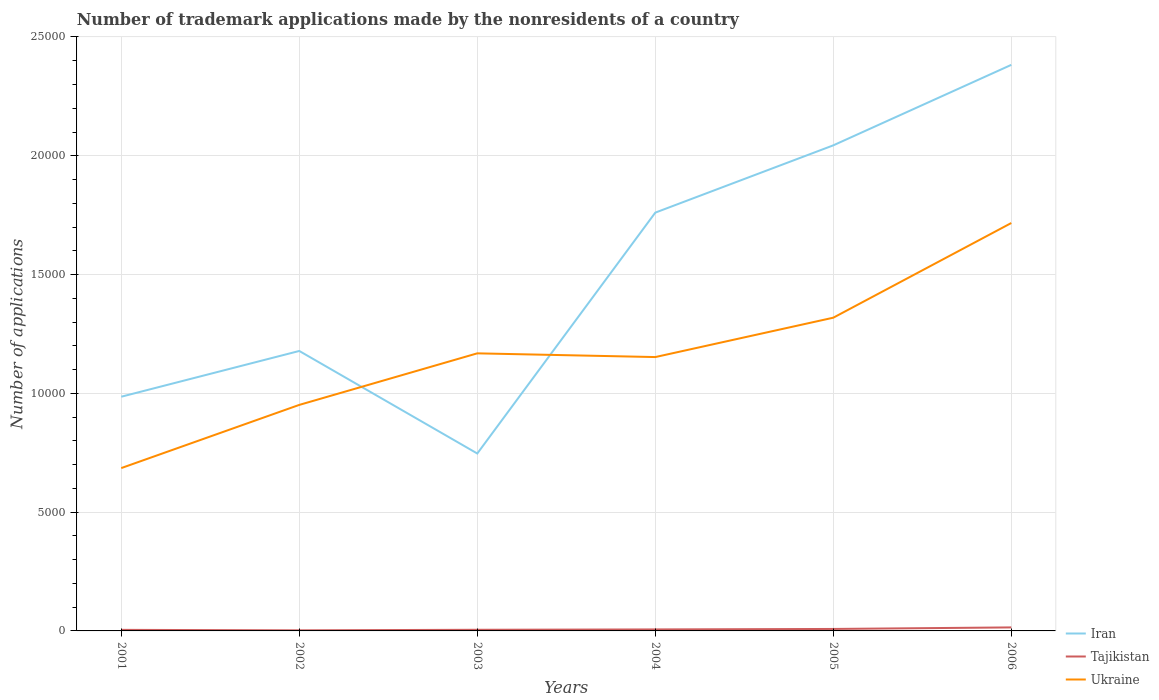Does the line corresponding to Tajikistan intersect with the line corresponding to Iran?
Your answer should be compact. No. Across all years, what is the maximum number of trademark applications made by the nonresidents in Ukraine?
Offer a very short reply. 6854. What is the total number of trademark applications made by the nonresidents in Tajikistan in the graph?
Offer a very short reply. -100. What is the difference between the highest and the second highest number of trademark applications made by the nonresidents in Tajikistan?
Provide a short and direct response. 123. What is the difference between the highest and the lowest number of trademark applications made by the nonresidents in Iran?
Your answer should be compact. 3. How many years are there in the graph?
Your answer should be very brief. 6. Does the graph contain any zero values?
Provide a succinct answer. No. Where does the legend appear in the graph?
Provide a succinct answer. Bottom right. How are the legend labels stacked?
Your answer should be very brief. Vertical. What is the title of the graph?
Your answer should be very brief. Number of trademark applications made by the nonresidents of a country. Does "China" appear as one of the legend labels in the graph?
Your response must be concise. No. What is the label or title of the X-axis?
Give a very brief answer. Years. What is the label or title of the Y-axis?
Your answer should be very brief. Number of applications. What is the Number of applications of Iran in 2001?
Provide a short and direct response. 9858. What is the Number of applications of Ukraine in 2001?
Offer a very short reply. 6854. What is the Number of applications of Iran in 2002?
Make the answer very short. 1.18e+04. What is the Number of applications in Ukraine in 2002?
Provide a succinct answer. 9514. What is the Number of applications of Iran in 2003?
Your answer should be compact. 7468. What is the Number of applications of Ukraine in 2003?
Your answer should be very brief. 1.17e+04. What is the Number of applications in Iran in 2004?
Ensure brevity in your answer.  1.76e+04. What is the Number of applications in Ukraine in 2004?
Make the answer very short. 1.15e+04. What is the Number of applications of Iran in 2005?
Your answer should be compact. 2.04e+04. What is the Number of applications of Ukraine in 2005?
Keep it short and to the point. 1.32e+04. What is the Number of applications in Iran in 2006?
Ensure brevity in your answer.  2.38e+04. What is the Number of applications in Tajikistan in 2006?
Provide a short and direct response. 148. What is the Number of applications of Ukraine in 2006?
Your answer should be very brief. 1.72e+04. Across all years, what is the maximum Number of applications in Iran?
Provide a short and direct response. 2.38e+04. Across all years, what is the maximum Number of applications of Tajikistan?
Give a very brief answer. 148. Across all years, what is the maximum Number of applications in Ukraine?
Provide a succinct answer. 1.72e+04. Across all years, what is the minimum Number of applications of Iran?
Provide a succinct answer. 7468. Across all years, what is the minimum Number of applications in Ukraine?
Ensure brevity in your answer.  6854. What is the total Number of applications in Iran in the graph?
Make the answer very short. 9.10e+04. What is the total Number of applications of Tajikistan in the graph?
Your response must be concise. 412. What is the total Number of applications in Ukraine in the graph?
Your answer should be very brief. 6.99e+04. What is the difference between the Number of applications of Iran in 2001 and that in 2002?
Your response must be concise. -1926. What is the difference between the Number of applications of Ukraine in 2001 and that in 2002?
Provide a short and direct response. -2660. What is the difference between the Number of applications in Iran in 2001 and that in 2003?
Offer a terse response. 2390. What is the difference between the Number of applications in Ukraine in 2001 and that in 2003?
Your answer should be very brief. -4830. What is the difference between the Number of applications in Iran in 2001 and that in 2004?
Make the answer very short. -7749. What is the difference between the Number of applications of Tajikistan in 2001 and that in 2004?
Give a very brief answer. -18. What is the difference between the Number of applications of Ukraine in 2001 and that in 2004?
Give a very brief answer. -4673. What is the difference between the Number of applications of Iran in 2001 and that in 2005?
Offer a terse response. -1.06e+04. What is the difference between the Number of applications of Tajikistan in 2001 and that in 2005?
Your answer should be compact. -38. What is the difference between the Number of applications in Ukraine in 2001 and that in 2005?
Make the answer very short. -6330. What is the difference between the Number of applications of Iran in 2001 and that in 2006?
Offer a terse response. -1.40e+04. What is the difference between the Number of applications in Tajikistan in 2001 and that in 2006?
Offer a terse response. -103. What is the difference between the Number of applications in Ukraine in 2001 and that in 2006?
Make the answer very short. -1.03e+04. What is the difference between the Number of applications in Iran in 2002 and that in 2003?
Ensure brevity in your answer.  4316. What is the difference between the Number of applications of Tajikistan in 2002 and that in 2003?
Your answer should be compact. -23. What is the difference between the Number of applications of Ukraine in 2002 and that in 2003?
Make the answer very short. -2170. What is the difference between the Number of applications in Iran in 2002 and that in 2004?
Keep it short and to the point. -5823. What is the difference between the Number of applications in Tajikistan in 2002 and that in 2004?
Offer a terse response. -38. What is the difference between the Number of applications in Ukraine in 2002 and that in 2004?
Make the answer very short. -2013. What is the difference between the Number of applications in Iran in 2002 and that in 2005?
Your answer should be very brief. -8655. What is the difference between the Number of applications in Tajikistan in 2002 and that in 2005?
Your answer should be very brief. -58. What is the difference between the Number of applications in Ukraine in 2002 and that in 2005?
Your answer should be very brief. -3670. What is the difference between the Number of applications of Iran in 2002 and that in 2006?
Provide a short and direct response. -1.20e+04. What is the difference between the Number of applications in Tajikistan in 2002 and that in 2006?
Give a very brief answer. -123. What is the difference between the Number of applications of Ukraine in 2002 and that in 2006?
Offer a terse response. -7656. What is the difference between the Number of applications in Iran in 2003 and that in 2004?
Make the answer very short. -1.01e+04. What is the difference between the Number of applications in Tajikistan in 2003 and that in 2004?
Keep it short and to the point. -15. What is the difference between the Number of applications of Ukraine in 2003 and that in 2004?
Give a very brief answer. 157. What is the difference between the Number of applications in Iran in 2003 and that in 2005?
Your response must be concise. -1.30e+04. What is the difference between the Number of applications of Tajikistan in 2003 and that in 2005?
Your response must be concise. -35. What is the difference between the Number of applications of Ukraine in 2003 and that in 2005?
Provide a succinct answer. -1500. What is the difference between the Number of applications of Iran in 2003 and that in 2006?
Offer a terse response. -1.64e+04. What is the difference between the Number of applications in Tajikistan in 2003 and that in 2006?
Offer a terse response. -100. What is the difference between the Number of applications in Ukraine in 2003 and that in 2006?
Your response must be concise. -5486. What is the difference between the Number of applications in Iran in 2004 and that in 2005?
Your response must be concise. -2832. What is the difference between the Number of applications in Ukraine in 2004 and that in 2005?
Offer a very short reply. -1657. What is the difference between the Number of applications of Iran in 2004 and that in 2006?
Your answer should be very brief. -6220. What is the difference between the Number of applications of Tajikistan in 2004 and that in 2006?
Keep it short and to the point. -85. What is the difference between the Number of applications of Ukraine in 2004 and that in 2006?
Ensure brevity in your answer.  -5643. What is the difference between the Number of applications of Iran in 2005 and that in 2006?
Your response must be concise. -3388. What is the difference between the Number of applications in Tajikistan in 2005 and that in 2006?
Provide a succinct answer. -65. What is the difference between the Number of applications of Ukraine in 2005 and that in 2006?
Offer a terse response. -3986. What is the difference between the Number of applications in Iran in 2001 and the Number of applications in Tajikistan in 2002?
Provide a succinct answer. 9833. What is the difference between the Number of applications of Iran in 2001 and the Number of applications of Ukraine in 2002?
Your answer should be compact. 344. What is the difference between the Number of applications in Tajikistan in 2001 and the Number of applications in Ukraine in 2002?
Offer a terse response. -9469. What is the difference between the Number of applications in Iran in 2001 and the Number of applications in Tajikistan in 2003?
Your response must be concise. 9810. What is the difference between the Number of applications of Iran in 2001 and the Number of applications of Ukraine in 2003?
Make the answer very short. -1826. What is the difference between the Number of applications of Tajikistan in 2001 and the Number of applications of Ukraine in 2003?
Provide a succinct answer. -1.16e+04. What is the difference between the Number of applications in Iran in 2001 and the Number of applications in Tajikistan in 2004?
Your answer should be compact. 9795. What is the difference between the Number of applications of Iran in 2001 and the Number of applications of Ukraine in 2004?
Your answer should be compact. -1669. What is the difference between the Number of applications in Tajikistan in 2001 and the Number of applications in Ukraine in 2004?
Make the answer very short. -1.15e+04. What is the difference between the Number of applications in Iran in 2001 and the Number of applications in Tajikistan in 2005?
Offer a terse response. 9775. What is the difference between the Number of applications of Iran in 2001 and the Number of applications of Ukraine in 2005?
Make the answer very short. -3326. What is the difference between the Number of applications in Tajikistan in 2001 and the Number of applications in Ukraine in 2005?
Your response must be concise. -1.31e+04. What is the difference between the Number of applications in Iran in 2001 and the Number of applications in Tajikistan in 2006?
Provide a short and direct response. 9710. What is the difference between the Number of applications in Iran in 2001 and the Number of applications in Ukraine in 2006?
Ensure brevity in your answer.  -7312. What is the difference between the Number of applications in Tajikistan in 2001 and the Number of applications in Ukraine in 2006?
Provide a succinct answer. -1.71e+04. What is the difference between the Number of applications of Iran in 2002 and the Number of applications of Tajikistan in 2003?
Offer a very short reply. 1.17e+04. What is the difference between the Number of applications of Iran in 2002 and the Number of applications of Ukraine in 2003?
Provide a short and direct response. 100. What is the difference between the Number of applications of Tajikistan in 2002 and the Number of applications of Ukraine in 2003?
Keep it short and to the point. -1.17e+04. What is the difference between the Number of applications in Iran in 2002 and the Number of applications in Tajikistan in 2004?
Provide a succinct answer. 1.17e+04. What is the difference between the Number of applications in Iran in 2002 and the Number of applications in Ukraine in 2004?
Offer a very short reply. 257. What is the difference between the Number of applications of Tajikistan in 2002 and the Number of applications of Ukraine in 2004?
Your answer should be very brief. -1.15e+04. What is the difference between the Number of applications in Iran in 2002 and the Number of applications in Tajikistan in 2005?
Your answer should be compact. 1.17e+04. What is the difference between the Number of applications of Iran in 2002 and the Number of applications of Ukraine in 2005?
Offer a very short reply. -1400. What is the difference between the Number of applications in Tajikistan in 2002 and the Number of applications in Ukraine in 2005?
Keep it short and to the point. -1.32e+04. What is the difference between the Number of applications of Iran in 2002 and the Number of applications of Tajikistan in 2006?
Provide a short and direct response. 1.16e+04. What is the difference between the Number of applications in Iran in 2002 and the Number of applications in Ukraine in 2006?
Keep it short and to the point. -5386. What is the difference between the Number of applications of Tajikistan in 2002 and the Number of applications of Ukraine in 2006?
Offer a terse response. -1.71e+04. What is the difference between the Number of applications of Iran in 2003 and the Number of applications of Tajikistan in 2004?
Provide a succinct answer. 7405. What is the difference between the Number of applications in Iran in 2003 and the Number of applications in Ukraine in 2004?
Your response must be concise. -4059. What is the difference between the Number of applications of Tajikistan in 2003 and the Number of applications of Ukraine in 2004?
Offer a very short reply. -1.15e+04. What is the difference between the Number of applications of Iran in 2003 and the Number of applications of Tajikistan in 2005?
Offer a very short reply. 7385. What is the difference between the Number of applications in Iran in 2003 and the Number of applications in Ukraine in 2005?
Your answer should be very brief. -5716. What is the difference between the Number of applications in Tajikistan in 2003 and the Number of applications in Ukraine in 2005?
Give a very brief answer. -1.31e+04. What is the difference between the Number of applications of Iran in 2003 and the Number of applications of Tajikistan in 2006?
Offer a very short reply. 7320. What is the difference between the Number of applications in Iran in 2003 and the Number of applications in Ukraine in 2006?
Offer a terse response. -9702. What is the difference between the Number of applications in Tajikistan in 2003 and the Number of applications in Ukraine in 2006?
Keep it short and to the point. -1.71e+04. What is the difference between the Number of applications in Iran in 2004 and the Number of applications in Tajikistan in 2005?
Give a very brief answer. 1.75e+04. What is the difference between the Number of applications of Iran in 2004 and the Number of applications of Ukraine in 2005?
Provide a succinct answer. 4423. What is the difference between the Number of applications in Tajikistan in 2004 and the Number of applications in Ukraine in 2005?
Your answer should be compact. -1.31e+04. What is the difference between the Number of applications in Iran in 2004 and the Number of applications in Tajikistan in 2006?
Keep it short and to the point. 1.75e+04. What is the difference between the Number of applications in Iran in 2004 and the Number of applications in Ukraine in 2006?
Keep it short and to the point. 437. What is the difference between the Number of applications of Tajikistan in 2004 and the Number of applications of Ukraine in 2006?
Your response must be concise. -1.71e+04. What is the difference between the Number of applications in Iran in 2005 and the Number of applications in Tajikistan in 2006?
Your response must be concise. 2.03e+04. What is the difference between the Number of applications in Iran in 2005 and the Number of applications in Ukraine in 2006?
Provide a short and direct response. 3269. What is the difference between the Number of applications of Tajikistan in 2005 and the Number of applications of Ukraine in 2006?
Offer a very short reply. -1.71e+04. What is the average Number of applications of Iran per year?
Keep it short and to the point. 1.52e+04. What is the average Number of applications of Tajikistan per year?
Offer a terse response. 68.67. What is the average Number of applications in Ukraine per year?
Offer a very short reply. 1.17e+04. In the year 2001, what is the difference between the Number of applications in Iran and Number of applications in Tajikistan?
Your answer should be compact. 9813. In the year 2001, what is the difference between the Number of applications in Iran and Number of applications in Ukraine?
Ensure brevity in your answer.  3004. In the year 2001, what is the difference between the Number of applications in Tajikistan and Number of applications in Ukraine?
Offer a very short reply. -6809. In the year 2002, what is the difference between the Number of applications of Iran and Number of applications of Tajikistan?
Give a very brief answer. 1.18e+04. In the year 2002, what is the difference between the Number of applications in Iran and Number of applications in Ukraine?
Ensure brevity in your answer.  2270. In the year 2002, what is the difference between the Number of applications in Tajikistan and Number of applications in Ukraine?
Offer a very short reply. -9489. In the year 2003, what is the difference between the Number of applications of Iran and Number of applications of Tajikistan?
Make the answer very short. 7420. In the year 2003, what is the difference between the Number of applications of Iran and Number of applications of Ukraine?
Ensure brevity in your answer.  -4216. In the year 2003, what is the difference between the Number of applications of Tajikistan and Number of applications of Ukraine?
Provide a short and direct response. -1.16e+04. In the year 2004, what is the difference between the Number of applications of Iran and Number of applications of Tajikistan?
Your answer should be very brief. 1.75e+04. In the year 2004, what is the difference between the Number of applications of Iran and Number of applications of Ukraine?
Keep it short and to the point. 6080. In the year 2004, what is the difference between the Number of applications in Tajikistan and Number of applications in Ukraine?
Offer a terse response. -1.15e+04. In the year 2005, what is the difference between the Number of applications of Iran and Number of applications of Tajikistan?
Your answer should be very brief. 2.04e+04. In the year 2005, what is the difference between the Number of applications of Iran and Number of applications of Ukraine?
Ensure brevity in your answer.  7255. In the year 2005, what is the difference between the Number of applications in Tajikistan and Number of applications in Ukraine?
Your response must be concise. -1.31e+04. In the year 2006, what is the difference between the Number of applications in Iran and Number of applications in Tajikistan?
Make the answer very short. 2.37e+04. In the year 2006, what is the difference between the Number of applications in Iran and Number of applications in Ukraine?
Provide a short and direct response. 6657. In the year 2006, what is the difference between the Number of applications of Tajikistan and Number of applications of Ukraine?
Your response must be concise. -1.70e+04. What is the ratio of the Number of applications of Iran in 2001 to that in 2002?
Provide a succinct answer. 0.84. What is the ratio of the Number of applications in Ukraine in 2001 to that in 2002?
Keep it short and to the point. 0.72. What is the ratio of the Number of applications of Iran in 2001 to that in 2003?
Your answer should be very brief. 1.32. What is the ratio of the Number of applications in Ukraine in 2001 to that in 2003?
Ensure brevity in your answer.  0.59. What is the ratio of the Number of applications of Iran in 2001 to that in 2004?
Provide a short and direct response. 0.56. What is the ratio of the Number of applications of Ukraine in 2001 to that in 2004?
Give a very brief answer. 0.59. What is the ratio of the Number of applications in Iran in 2001 to that in 2005?
Provide a succinct answer. 0.48. What is the ratio of the Number of applications of Tajikistan in 2001 to that in 2005?
Ensure brevity in your answer.  0.54. What is the ratio of the Number of applications of Ukraine in 2001 to that in 2005?
Offer a very short reply. 0.52. What is the ratio of the Number of applications in Iran in 2001 to that in 2006?
Your answer should be compact. 0.41. What is the ratio of the Number of applications in Tajikistan in 2001 to that in 2006?
Offer a terse response. 0.3. What is the ratio of the Number of applications of Ukraine in 2001 to that in 2006?
Offer a terse response. 0.4. What is the ratio of the Number of applications of Iran in 2002 to that in 2003?
Keep it short and to the point. 1.58. What is the ratio of the Number of applications in Tajikistan in 2002 to that in 2003?
Make the answer very short. 0.52. What is the ratio of the Number of applications in Ukraine in 2002 to that in 2003?
Make the answer very short. 0.81. What is the ratio of the Number of applications of Iran in 2002 to that in 2004?
Ensure brevity in your answer.  0.67. What is the ratio of the Number of applications in Tajikistan in 2002 to that in 2004?
Make the answer very short. 0.4. What is the ratio of the Number of applications of Ukraine in 2002 to that in 2004?
Keep it short and to the point. 0.83. What is the ratio of the Number of applications in Iran in 2002 to that in 2005?
Provide a succinct answer. 0.58. What is the ratio of the Number of applications in Tajikistan in 2002 to that in 2005?
Keep it short and to the point. 0.3. What is the ratio of the Number of applications of Ukraine in 2002 to that in 2005?
Offer a very short reply. 0.72. What is the ratio of the Number of applications in Iran in 2002 to that in 2006?
Offer a terse response. 0.49. What is the ratio of the Number of applications of Tajikistan in 2002 to that in 2006?
Make the answer very short. 0.17. What is the ratio of the Number of applications in Ukraine in 2002 to that in 2006?
Provide a short and direct response. 0.55. What is the ratio of the Number of applications in Iran in 2003 to that in 2004?
Provide a short and direct response. 0.42. What is the ratio of the Number of applications in Tajikistan in 2003 to that in 2004?
Keep it short and to the point. 0.76. What is the ratio of the Number of applications in Ukraine in 2003 to that in 2004?
Your answer should be very brief. 1.01. What is the ratio of the Number of applications of Iran in 2003 to that in 2005?
Your answer should be very brief. 0.37. What is the ratio of the Number of applications of Tajikistan in 2003 to that in 2005?
Keep it short and to the point. 0.58. What is the ratio of the Number of applications of Ukraine in 2003 to that in 2005?
Your response must be concise. 0.89. What is the ratio of the Number of applications of Iran in 2003 to that in 2006?
Offer a very short reply. 0.31. What is the ratio of the Number of applications of Tajikistan in 2003 to that in 2006?
Your answer should be very brief. 0.32. What is the ratio of the Number of applications in Ukraine in 2003 to that in 2006?
Your response must be concise. 0.68. What is the ratio of the Number of applications of Iran in 2004 to that in 2005?
Provide a succinct answer. 0.86. What is the ratio of the Number of applications in Tajikistan in 2004 to that in 2005?
Your response must be concise. 0.76. What is the ratio of the Number of applications of Ukraine in 2004 to that in 2005?
Your answer should be very brief. 0.87. What is the ratio of the Number of applications of Iran in 2004 to that in 2006?
Provide a succinct answer. 0.74. What is the ratio of the Number of applications of Tajikistan in 2004 to that in 2006?
Give a very brief answer. 0.43. What is the ratio of the Number of applications in Ukraine in 2004 to that in 2006?
Your answer should be very brief. 0.67. What is the ratio of the Number of applications of Iran in 2005 to that in 2006?
Offer a terse response. 0.86. What is the ratio of the Number of applications of Tajikistan in 2005 to that in 2006?
Your response must be concise. 0.56. What is the ratio of the Number of applications in Ukraine in 2005 to that in 2006?
Your answer should be compact. 0.77. What is the difference between the highest and the second highest Number of applications in Iran?
Keep it short and to the point. 3388. What is the difference between the highest and the second highest Number of applications of Ukraine?
Your answer should be compact. 3986. What is the difference between the highest and the lowest Number of applications of Iran?
Your answer should be compact. 1.64e+04. What is the difference between the highest and the lowest Number of applications of Tajikistan?
Ensure brevity in your answer.  123. What is the difference between the highest and the lowest Number of applications of Ukraine?
Your response must be concise. 1.03e+04. 